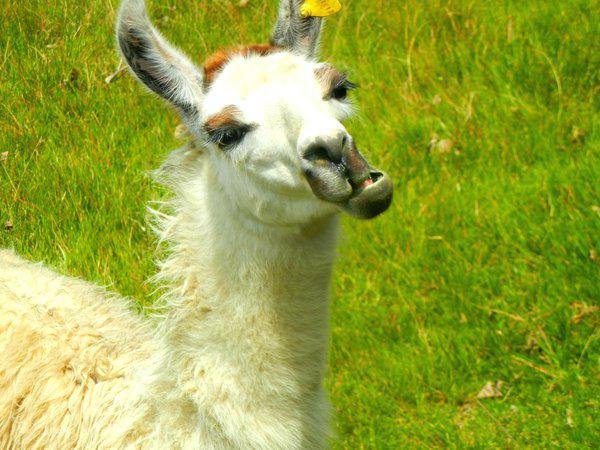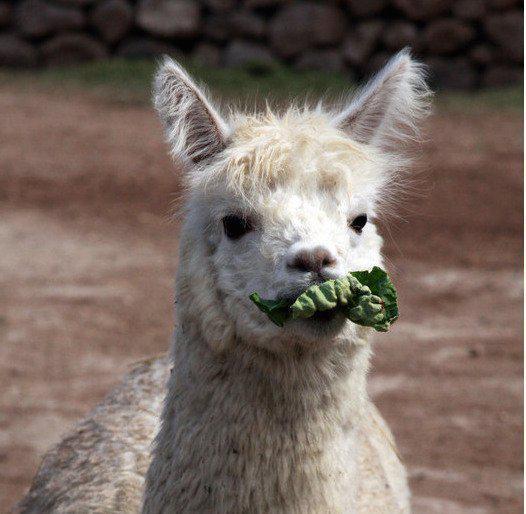The first image is the image on the left, the second image is the image on the right. Assess this claim about the two images: "At least one llama has food in its mouth.". Correct or not? Answer yes or no. Yes. The first image is the image on the left, the second image is the image on the right. Evaluate the accuracy of this statement regarding the images: "There are three mammals in total.". Is it true? Answer yes or no. No. 